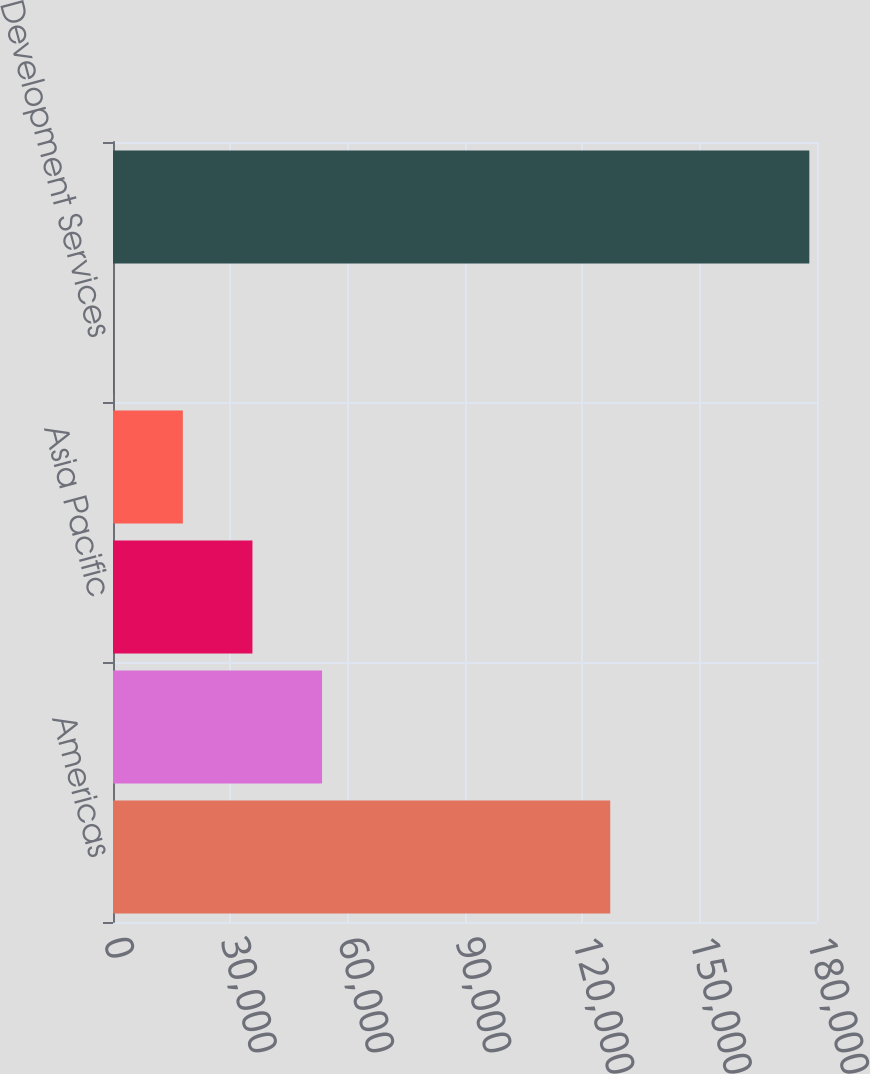Convert chart to OTSL. <chart><loc_0><loc_0><loc_500><loc_500><bar_chart><fcel>Americas<fcel>EMEA<fcel>Asia Pacific<fcel>Global Investment Management<fcel>Development Services<fcel>Total capital expenditures<nl><fcel>127135<fcel>53451.1<fcel>35652.4<fcel>17853.7<fcel>55<fcel>178042<nl></chart> 